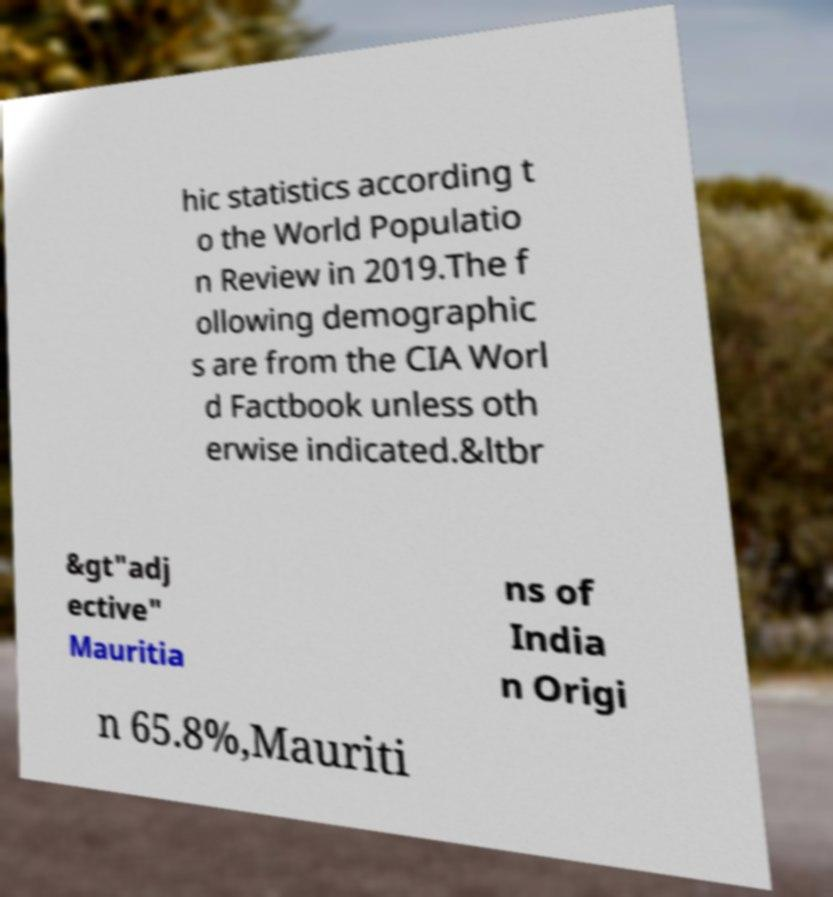There's text embedded in this image that I need extracted. Can you transcribe it verbatim? hic statistics according t o the World Populatio n Review in 2019.The f ollowing demographic s are from the CIA Worl d Factbook unless oth erwise indicated.&ltbr &gt"adj ective" Mauritia ns of India n Origi n 65.8%,Mauriti 